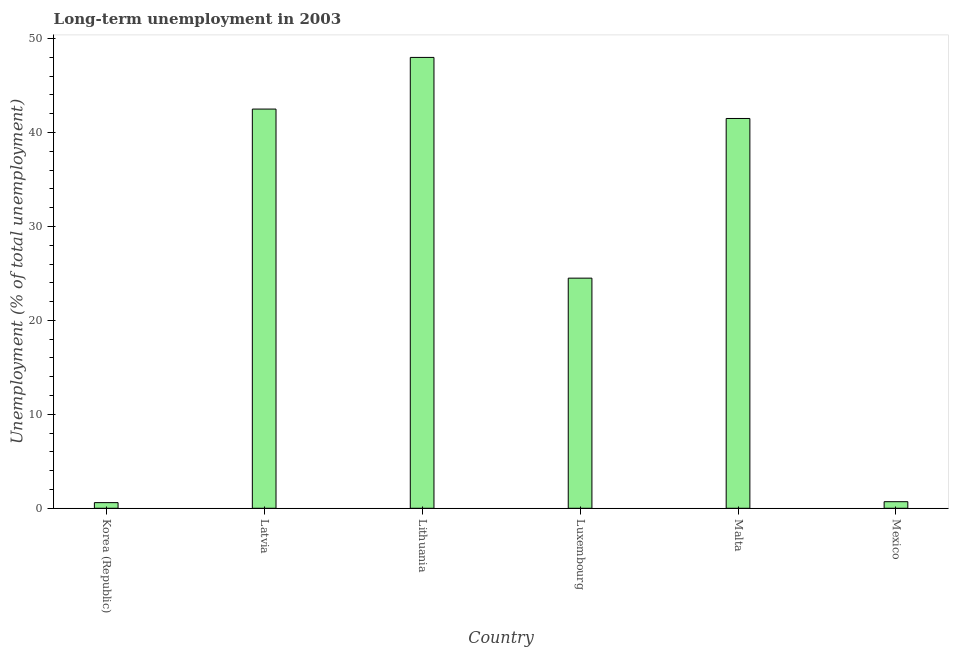Does the graph contain grids?
Your response must be concise. No. What is the title of the graph?
Your answer should be very brief. Long-term unemployment in 2003. What is the label or title of the X-axis?
Offer a terse response. Country. What is the label or title of the Y-axis?
Keep it short and to the point. Unemployment (% of total unemployment). What is the long-term unemployment in Latvia?
Provide a short and direct response. 42.5. Across all countries, what is the maximum long-term unemployment?
Keep it short and to the point. 48. Across all countries, what is the minimum long-term unemployment?
Your response must be concise. 0.6. In which country was the long-term unemployment maximum?
Provide a succinct answer. Lithuania. In which country was the long-term unemployment minimum?
Offer a very short reply. Korea (Republic). What is the sum of the long-term unemployment?
Ensure brevity in your answer.  157.8. What is the difference between the long-term unemployment in Latvia and Lithuania?
Offer a terse response. -5.5. What is the average long-term unemployment per country?
Your response must be concise. 26.3. What is the median long-term unemployment?
Ensure brevity in your answer.  33. In how many countries, is the long-term unemployment greater than 34 %?
Ensure brevity in your answer.  3. What is the ratio of the long-term unemployment in Korea (Republic) to that in Malta?
Your answer should be very brief. 0.01. Is the long-term unemployment in Lithuania less than that in Luxembourg?
Make the answer very short. No. Is the difference between the long-term unemployment in Latvia and Luxembourg greater than the difference between any two countries?
Offer a very short reply. No. What is the difference between the highest and the second highest long-term unemployment?
Offer a terse response. 5.5. Is the sum of the long-term unemployment in Korea (Republic) and Latvia greater than the maximum long-term unemployment across all countries?
Offer a terse response. No. What is the difference between the highest and the lowest long-term unemployment?
Keep it short and to the point. 47.4. How many bars are there?
Your answer should be compact. 6. What is the difference between two consecutive major ticks on the Y-axis?
Give a very brief answer. 10. Are the values on the major ticks of Y-axis written in scientific E-notation?
Provide a succinct answer. No. What is the Unemployment (% of total unemployment) in Korea (Republic)?
Provide a short and direct response. 0.6. What is the Unemployment (% of total unemployment) in Latvia?
Your answer should be compact. 42.5. What is the Unemployment (% of total unemployment) in Luxembourg?
Ensure brevity in your answer.  24.5. What is the Unemployment (% of total unemployment) in Malta?
Your answer should be very brief. 41.5. What is the Unemployment (% of total unemployment) of Mexico?
Your answer should be very brief. 0.7. What is the difference between the Unemployment (% of total unemployment) in Korea (Republic) and Latvia?
Provide a short and direct response. -41.9. What is the difference between the Unemployment (% of total unemployment) in Korea (Republic) and Lithuania?
Provide a succinct answer. -47.4. What is the difference between the Unemployment (% of total unemployment) in Korea (Republic) and Luxembourg?
Your answer should be compact. -23.9. What is the difference between the Unemployment (% of total unemployment) in Korea (Republic) and Malta?
Offer a terse response. -40.9. What is the difference between the Unemployment (% of total unemployment) in Korea (Republic) and Mexico?
Your answer should be compact. -0.1. What is the difference between the Unemployment (% of total unemployment) in Latvia and Lithuania?
Your answer should be very brief. -5.5. What is the difference between the Unemployment (% of total unemployment) in Latvia and Malta?
Give a very brief answer. 1. What is the difference between the Unemployment (% of total unemployment) in Latvia and Mexico?
Provide a short and direct response. 41.8. What is the difference between the Unemployment (% of total unemployment) in Lithuania and Luxembourg?
Offer a terse response. 23.5. What is the difference between the Unemployment (% of total unemployment) in Lithuania and Mexico?
Your answer should be very brief. 47.3. What is the difference between the Unemployment (% of total unemployment) in Luxembourg and Mexico?
Provide a short and direct response. 23.8. What is the difference between the Unemployment (% of total unemployment) in Malta and Mexico?
Provide a short and direct response. 40.8. What is the ratio of the Unemployment (% of total unemployment) in Korea (Republic) to that in Latvia?
Give a very brief answer. 0.01. What is the ratio of the Unemployment (% of total unemployment) in Korea (Republic) to that in Lithuania?
Make the answer very short. 0.01. What is the ratio of the Unemployment (% of total unemployment) in Korea (Republic) to that in Luxembourg?
Your response must be concise. 0.02. What is the ratio of the Unemployment (% of total unemployment) in Korea (Republic) to that in Malta?
Your answer should be very brief. 0.01. What is the ratio of the Unemployment (% of total unemployment) in Korea (Republic) to that in Mexico?
Your response must be concise. 0.86. What is the ratio of the Unemployment (% of total unemployment) in Latvia to that in Lithuania?
Keep it short and to the point. 0.89. What is the ratio of the Unemployment (% of total unemployment) in Latvia to that in Luxembourg?
Ensure brevity in your answer.  1.74. What is the ratio of the Unemployment (% of total unemployment) in Latvia to that in Mexico?
Offer a very short reply. 60.71. What is the ratio of the Unemployment (% of total unemployment) in Lithuania to that in Luxembourg?
Make the answer very short. 1.96. What is the ratio of the Unemployment (% of total unemployment) in Lithuania to that in Malta?
Your response must be concise. 1.16. What is the ratio of the Unemployment (% of total unemployment) in Lithuania to that in Mexico?
Offer a very short reply. 68.57. What is the ratio of the Unemployment (% of total unemployment) in Luxembourg to that in Malta?
Offer a terse response. 0.59. What is the ratio of the Unemployment (% of total unemployment) in Luxembourg to that in Mexico?
Ensure brevity in your answer.  35. What is the ratio of the Unemployment (% of total unemployment) in Malta to that in Mexico?
Your response must be concise. 59.29. 